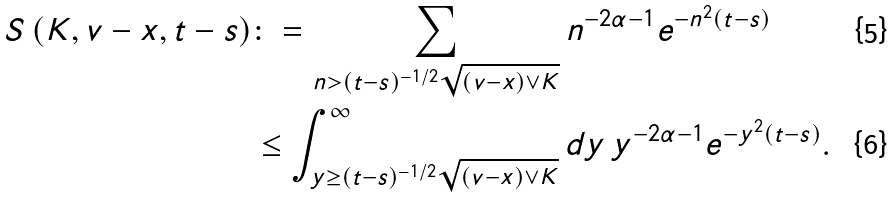Convert formula to latex. <formula><loc_0><loc_0><loc_500><loc_500>S \left ( K , v - x , t - s \right ) & \colon = \sum _ { n > ( t - s ) ^ { - 1 / 2 } \sqrt { ( v - x ) \vee K } } n ^ { - 2 \alpha - 1 } e ^ { - n ^ { 2 } ( t - s ) } \\ & \leq \int _ { y \geq ( t - s ) ^ { - 1 / 2 } \sqrt { ( v - x ) \vee K } } ^ { \infty } d y \, y ^ { - 2 \alpha - 1 } e ^ { - y ^ { 2 } ( t - s ) } .</formula> 